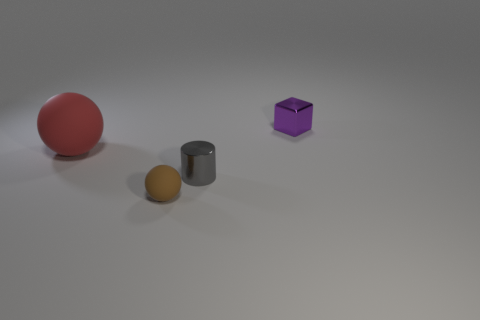Add 1 tiny brown matte things. How many objects exist? 5 Subtract all blocks. How many objects are left? 3 Subtract 0 blue cubes. How many objects are left? 4 Subtract all blue cubes. Subtract all metal objects. How many objects are left? 2 Add 1 rubber spheres. How many rubber spheres are left? 3 Add 3 tiny gray objects. How many tiny gray objects exist? 4 